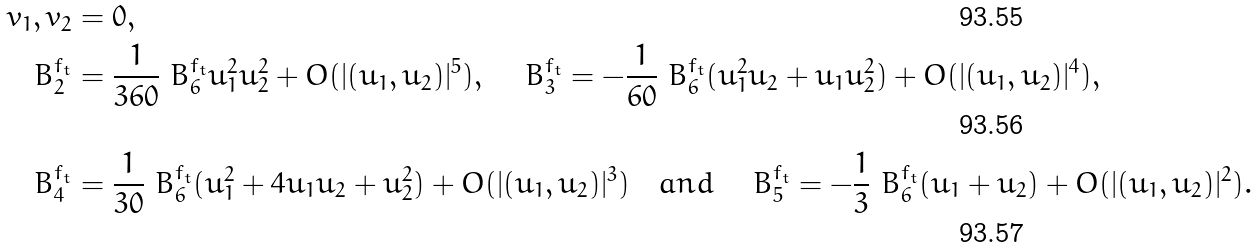<formula> <loc_0><loc_0><loc_500><loc_500>v _ { 1 } , v _ { 2 } & = 0 , \\ \ B ^ { f _ { t } } _ { 2 } & = \frac { 1 } { 3 6 0 } \ B ^ { f _ { t } } _ { 6 } u _ { 1 } ^ { 2 } u _ { 2 } ^ { 2 } + O ( | ( u _ { 1 } , u _ { 2 } ) | ^ { 5 } ) , \quad \ B ^ { f _ { t } } _ { 3 } = - \frac { 1 } { 6 0 } \ B ^ { f _ { t } } _ { 6 } ( u _ { 1 } ^ { 2 } u _ { 2 } + u _ { 1 } u _ { 2 } ^ { 2 } ) + O ( | ( u _ { 1 } , u _ { 2 } ) | ^ { 4 } ) , \\ \ B ^ { f _ { t } } _ { 4 } & = \frac { 1 } { 3 0 } \ B ^ { f _ { t } } _ { 6 } ( u _ { 1 } ^ { 2 } + 4 u _ { 1 } u _ { 2 } + u _ { 2 } ^ { 2 } ) + O ( | ( u _ { 1 } , u _ { 2 } ) | ^ { 3 } ) \quad a n d \quad \ B ^ { f _ { t } } _ { 5 } = - \frac { 1 } { 3 } \ B ^ { f _ { t } } _ { 6 } ( u _ { 1 } + u _ { 2 } ) + O ( | ( u _ { 1 } , u _ { 2 } ) | ^ { 2 } ) .</formula> 